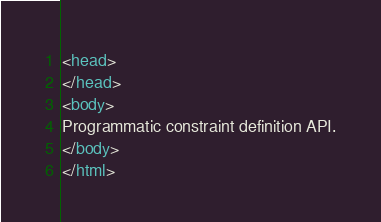Convert code to text. <code><loc_0><loc_0><loc_500><loc_500><_HTML_><head>
</head>
<body>
Programmatic constraint definition API.
</body>
</html>
</code> 